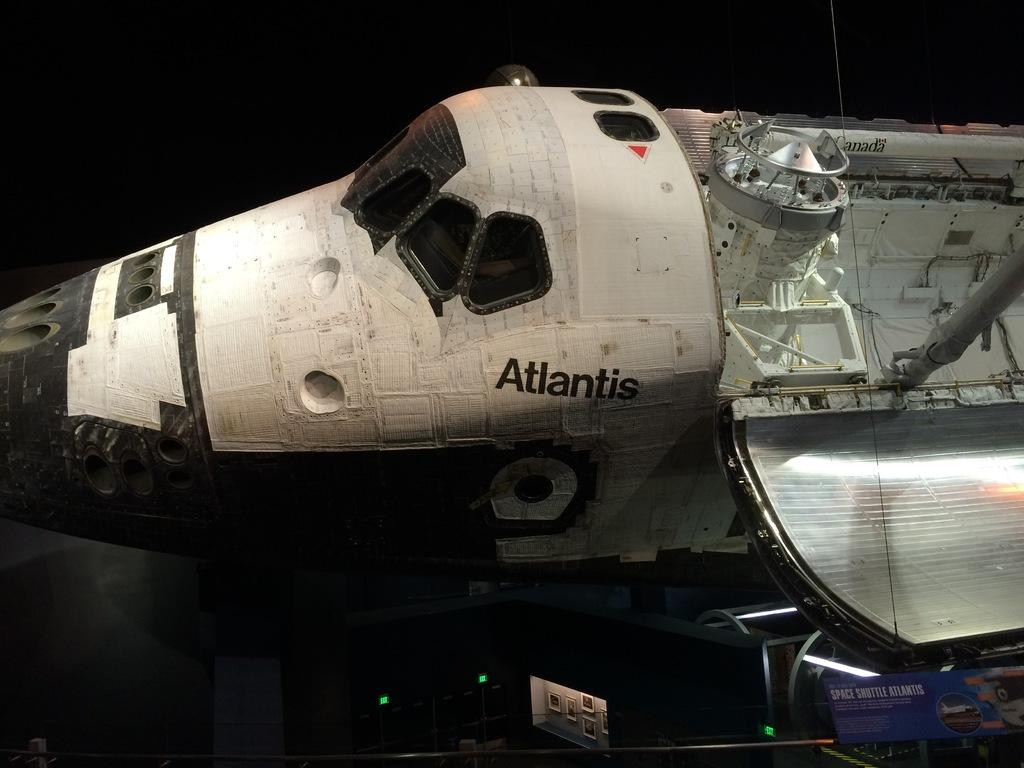Provide a one-sentence caption for the provided image. A old space shuttle with the word Atlantis on it. 